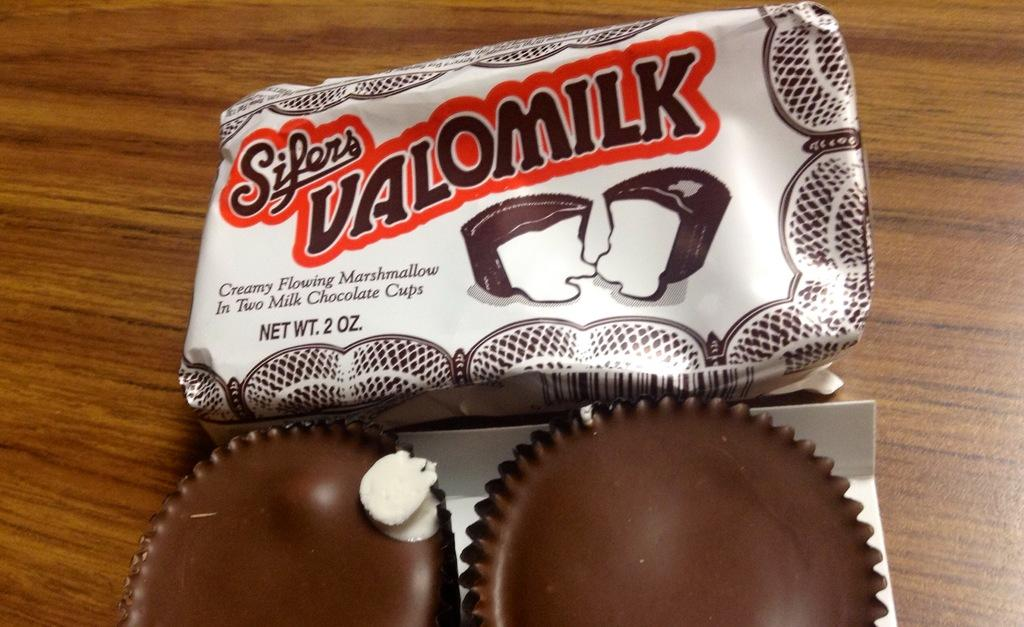What type of cups are in the image? There are two chocolate cups in the image. What is the color of the sheet on which the cups are placed? The chocolate cups are on a white sheet. What is the material of the table on which the sheet is placed? The white sheet is on a wooden table. What else can be seen in the image besides the chocolate cups and the white sheet? There is a packet in the image, located beside the white sheet. How does the aunt wash the wool in the image? There is no aunt, wool, or washing activity depicted in the image. 